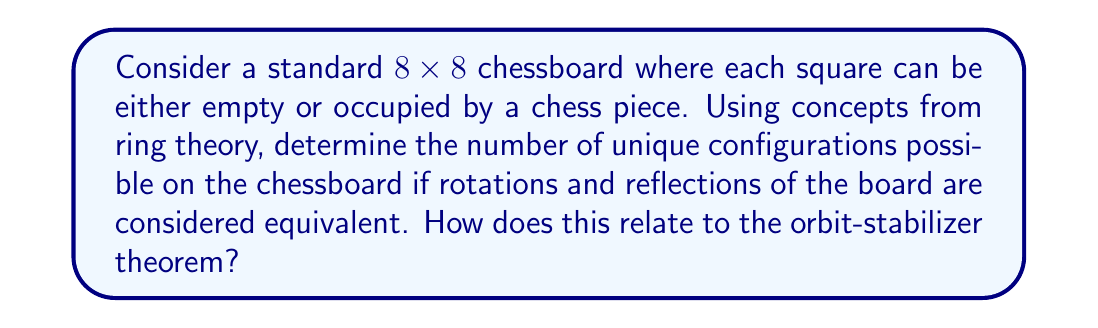Show me your answer to this math problem. To solve this problem, we'll use concepts from ring theory and group theory:

1) First, let's consider the total number of possible configurations without accounting for symmetries:
   Each square can be in 2 states (empty or occupied), and there are 64 squares.
   Total configurations = $2^{64}$

2) Now, we need to account for the symmetries of the chessboard. The symmetry group of a square (dihedral group D4) has 8 elements:
   - 4 rotations (0°, 90°, 180°, 270°)
   - 4 reflections (horizontal, vertical, two diagonals)

3) By the orbit-stabilizer theorem:
   $|Orbit(x)| = \frac{|G|}{|Stab(x)|}$
   Where $G$ is the symmetry group (D4 in this case), and $Stab(x)$ is the stabilizer of a configuration $x$.

4) The number of unique configurations is equal to the number of orbits. We can use Burnside's lemma to count the orbits:
   $|X/G| = \frac{1}{|G|} \sum_{g \in G} |X^g|$
   Where $X$ is the set of all configurations, and $X^g$ is the set of configurations fixed by the group element $g$.

5) Now, we need to count the fixed points for each symmetry:
   - Identity: All $2^{64}$ configurations are fixed
   - 90° and 270° rotations: $2^{36}$ configurations are fixed (4 central squares, 8 squares in each quadrant)
   - 180° rotation: $2^{32}$ configurations are fixed (4 central squares, 28 squares in symmetric pairs)
   - Reflections: $2^{32}$ configurations are fixed for each reflection (32 squares on the axis of symmetry)

6) Applying Burnside's lemma:
   $|X/G| = \frac{1}{8}(2^{64} + 2 \cdot 2^{36} + 2^{32} + 4 \cdot 2^{32})$

7) Simplifying:
   $|X/G| = \frac{1}{8}(2^{64} + 2 \cdot 2^{36} + 5 \cdot 2^{32})$

This gives us the number of unique configurations under the symmetry group D4.

The relationship to ring theory comes from the fact that we're working with a finite group (D4) acting on a set (chessboard configurations). The orbits form a partition of the set, which can be viewed as a quotient ring structure.
Answer: The number of unique configurations on the chessboard, accounting for rotations and reflections, is:

$$\frac{1}{8}(2^{64} + 2 \cdot 2^{36} + 5 \cdot 2^{32})$$

This result is obtained using Burnside's lemma, which is closely related to the orbit-stabilizer theorem in group theory. 